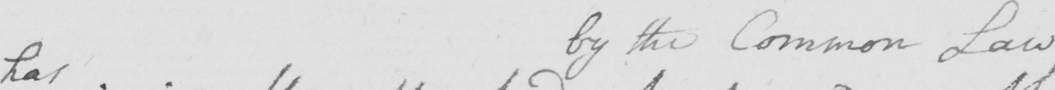Can you read and transcribe this handwriting? has by the Common Laws 